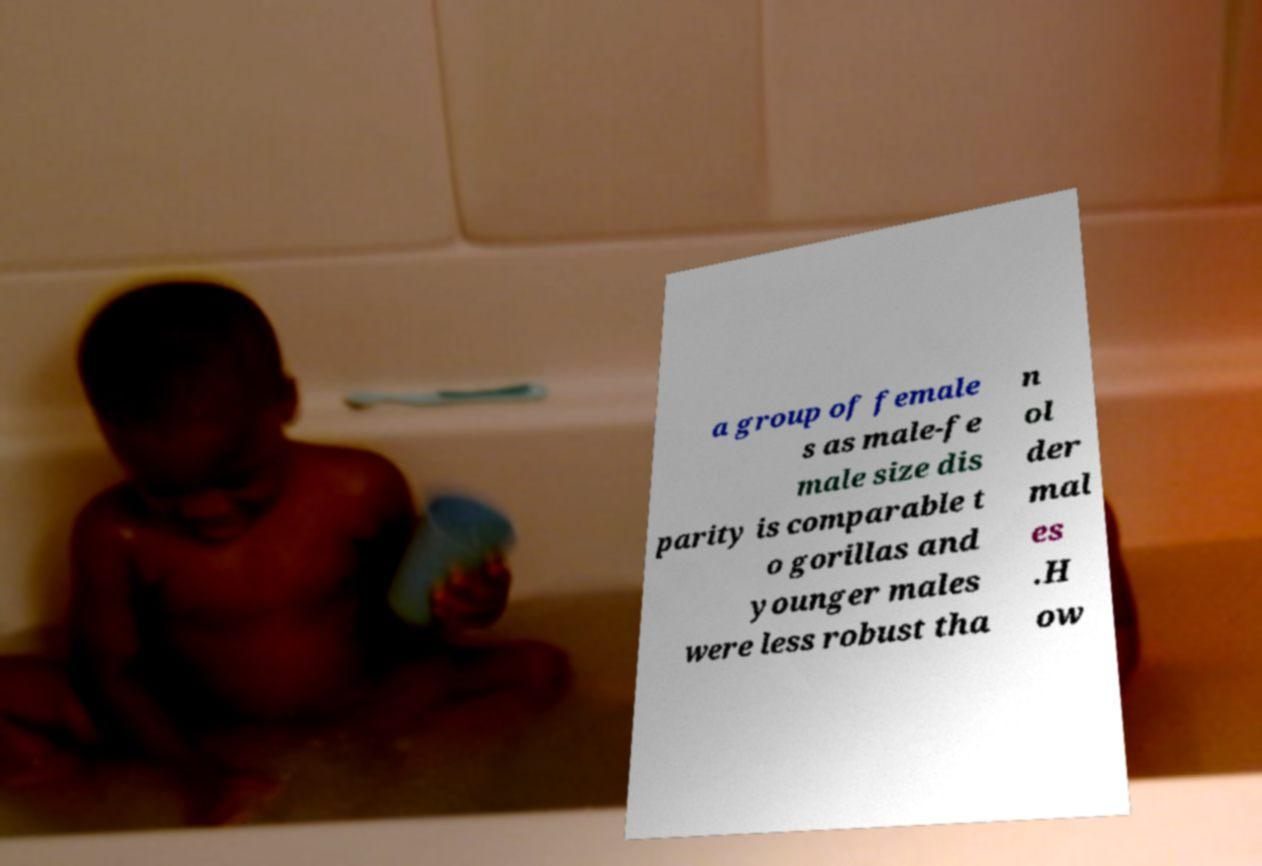Could you assist in decoding the text presented in this image and type it out clearly? a group of female s as male-fe male size dis parity is comparable t o gorillas and younger males were less robust tha n ol der mal es .H ow 